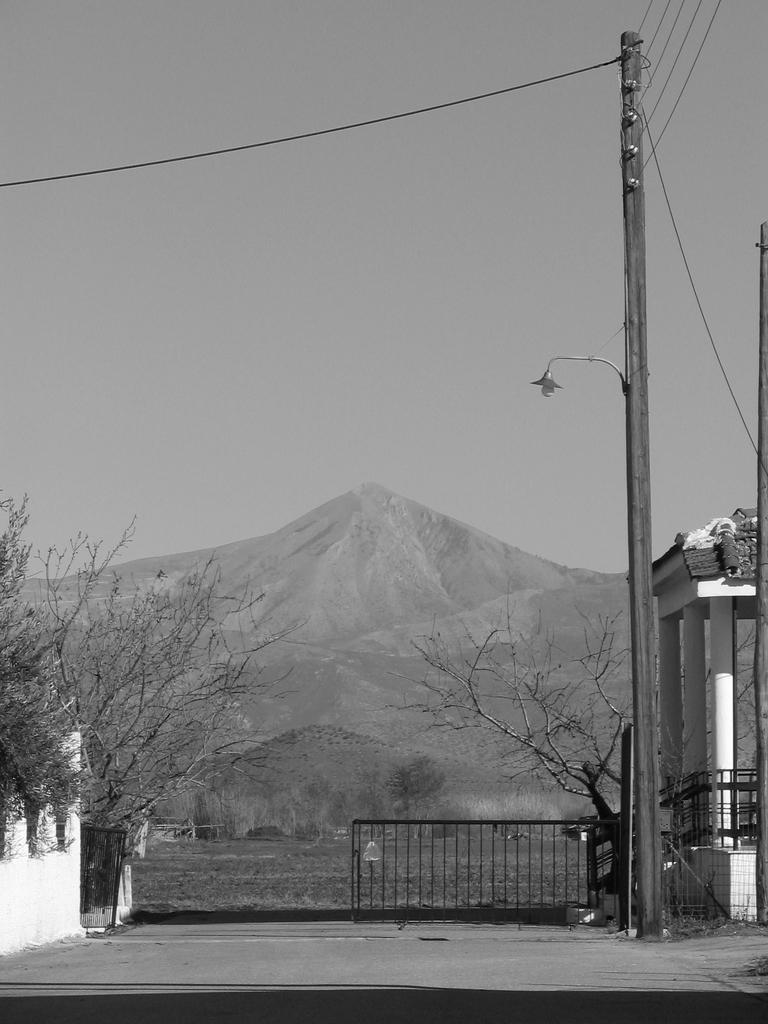What type of structure can be seen in the image? There is an electric pole in the image. What is attached to the electric pole? There is a light attached to the electric pole. What else can be seen connected to the electric pole? Electric wires are visible in the image. What type of natural elements are present in the image? There are trees and a mountain in the image. What type of man-made structures can be seen in the image? There is a fence and pillars in the image. What part of the natural environment is visible in the image? The sky is visible in the image. Where is the cobweb located in the image? There is no cobweb present in the image. What type of toy can be seen in the image? There are no toys present in the image. 